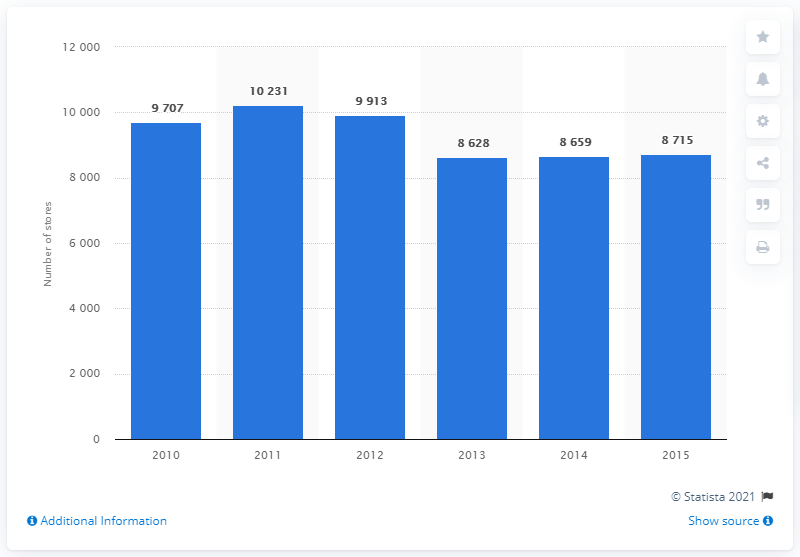Mention a couple of crucial points in this snapshot. In 2013, there were 9,913 supermarkets in Italy. 